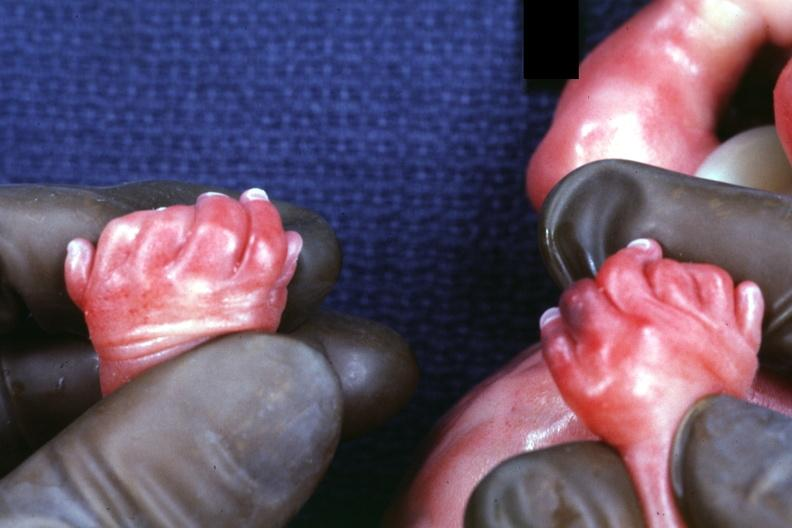does pituitary show child has polycystic disease?
Answer the question using a single word or phrase. No 